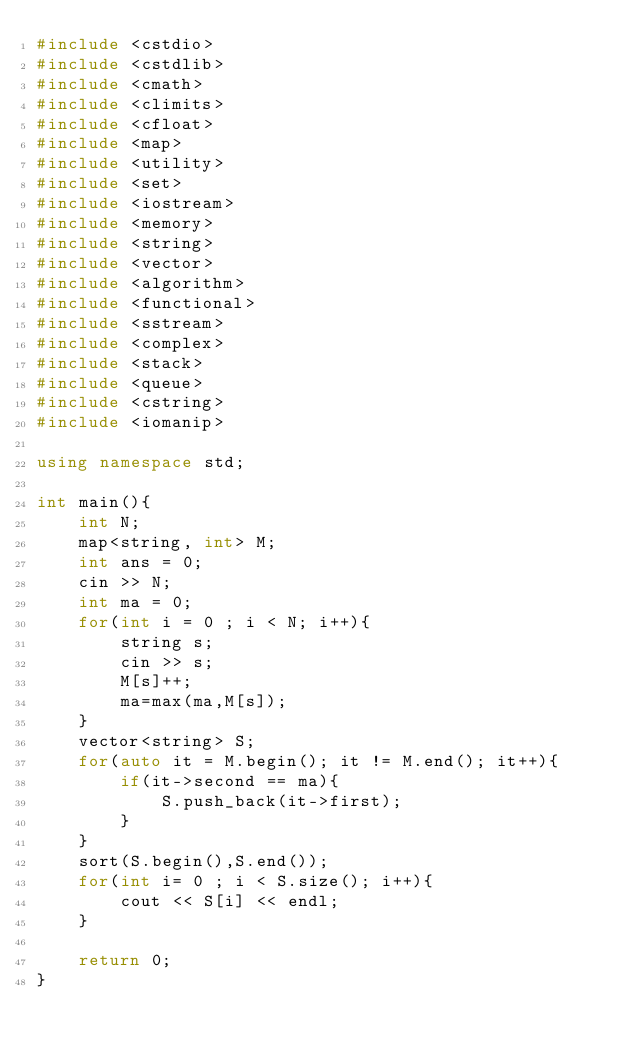<code> <loc_0><loc_0><loc_500><loc_500><_C++_>#include <cstdio>
#include <cstdlib>
#include <cmath>
#include <climits>
#include <cfloat>
#include <map>
#include <utility>
#include <set>
#include <iostream>
#include <memory>
#include <string>
#include <vector>
#include <algorithm>
#include <functional>
#include <sstream>
#include <complex>
#include <stack>
#include <queue>
#include <cstring>
#include <iomanip>

using namespace std;

int main(){
    int N;
    map<string, int> M;
    int ans = 0;
    cin >> N;
    int ma = 0;
    for(int i = 0 ; i < N; i++){
        string s;
        cin >> s;
        M[s]++;
        ma=max(ma,M[s]);
    }
    vector<string> S;
    for(auto it = M.begin(); it != M.end(); it++){
        if(it->second == ma){
            S.push_back(it->first);
        }
    }
    sort(S.begin(),S.end());
    for(int i= 0 ; i < S.size(); i++){
        cout << S[i] << endl;
    }

    return 0;
}
</code> 